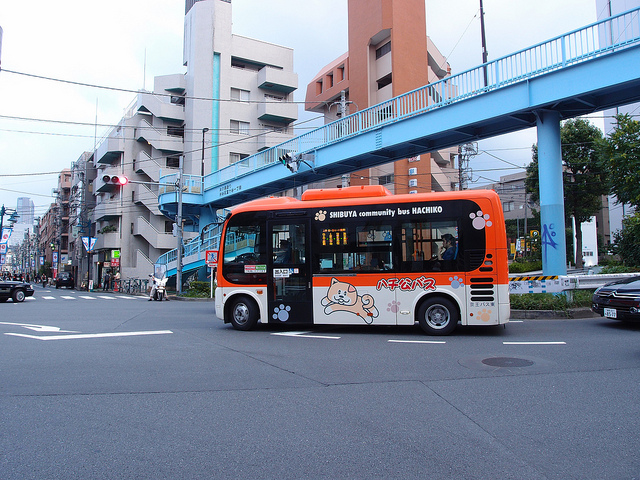Identify and read out the text in this image. SHIBUYA community bus HACHIKO 